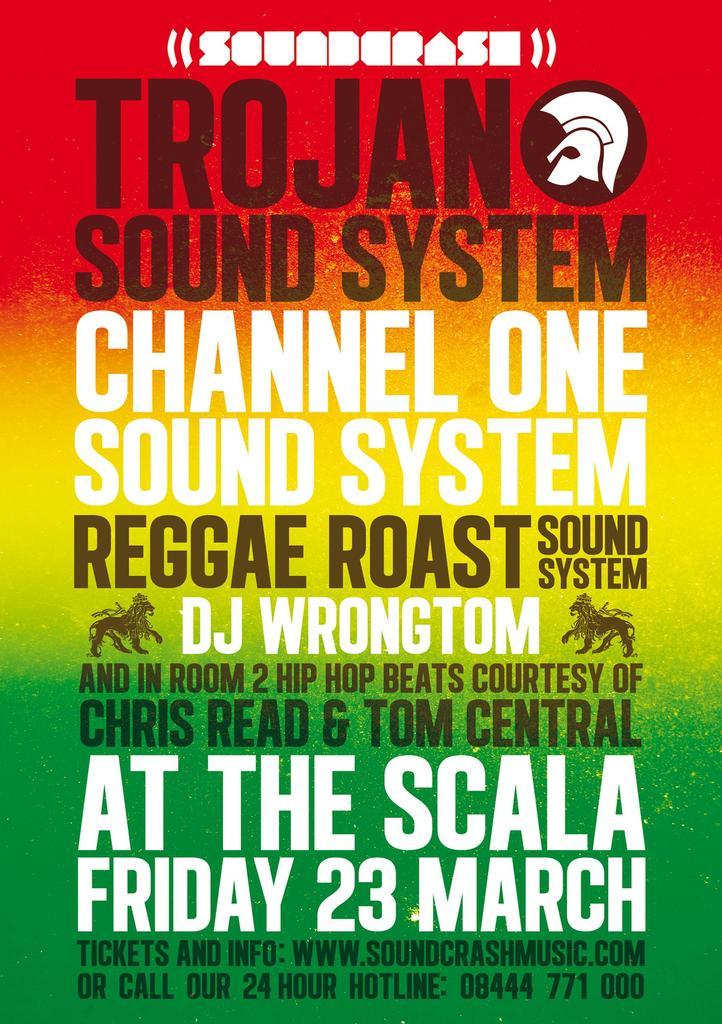When is this event taking place?
Offer a terse response. Friday 23 march. What month does this take place?
Provide a short and direct response. March. 